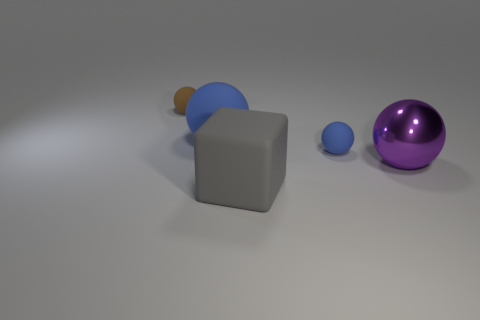What is the material of the large thing that is to the right of the big gray matte cube?
Keep it short and to the point. Metal. What number of small blue things have the same material as the big gray object?
Provide a succinct answer. 1. What shape is the object that is both left of the gray cube and to the right of the brown rubber ball?
Keep it short and to the point. Sphere. What number of objects are matte things behind the big blue matte ball or matte spheres on the right side of the big blue matte object?
Provide a succinct answer. 2. Is the number of tiny blue objects behind the brown matte object the same as the number of blue matte things that are behind the big blue rubber ball?
Offer a terse response. Yes. What shape is the thing that is left of the big sphere left of the metal thing?
Provide a short and direct response. Sphere. Is there another small object of the same shape as the tiny blue thing?
Your response must be concise. Yes. What number of large yellow matte cylinders are there?
Your response must be concise. 0. Is the material of the big object that is in front of the metal sphere the same as the small brown thing?
Provide a succinct answer. Yes. Are there any matte things of the same size as the gray block?
Offer a very short reply. Yes. 